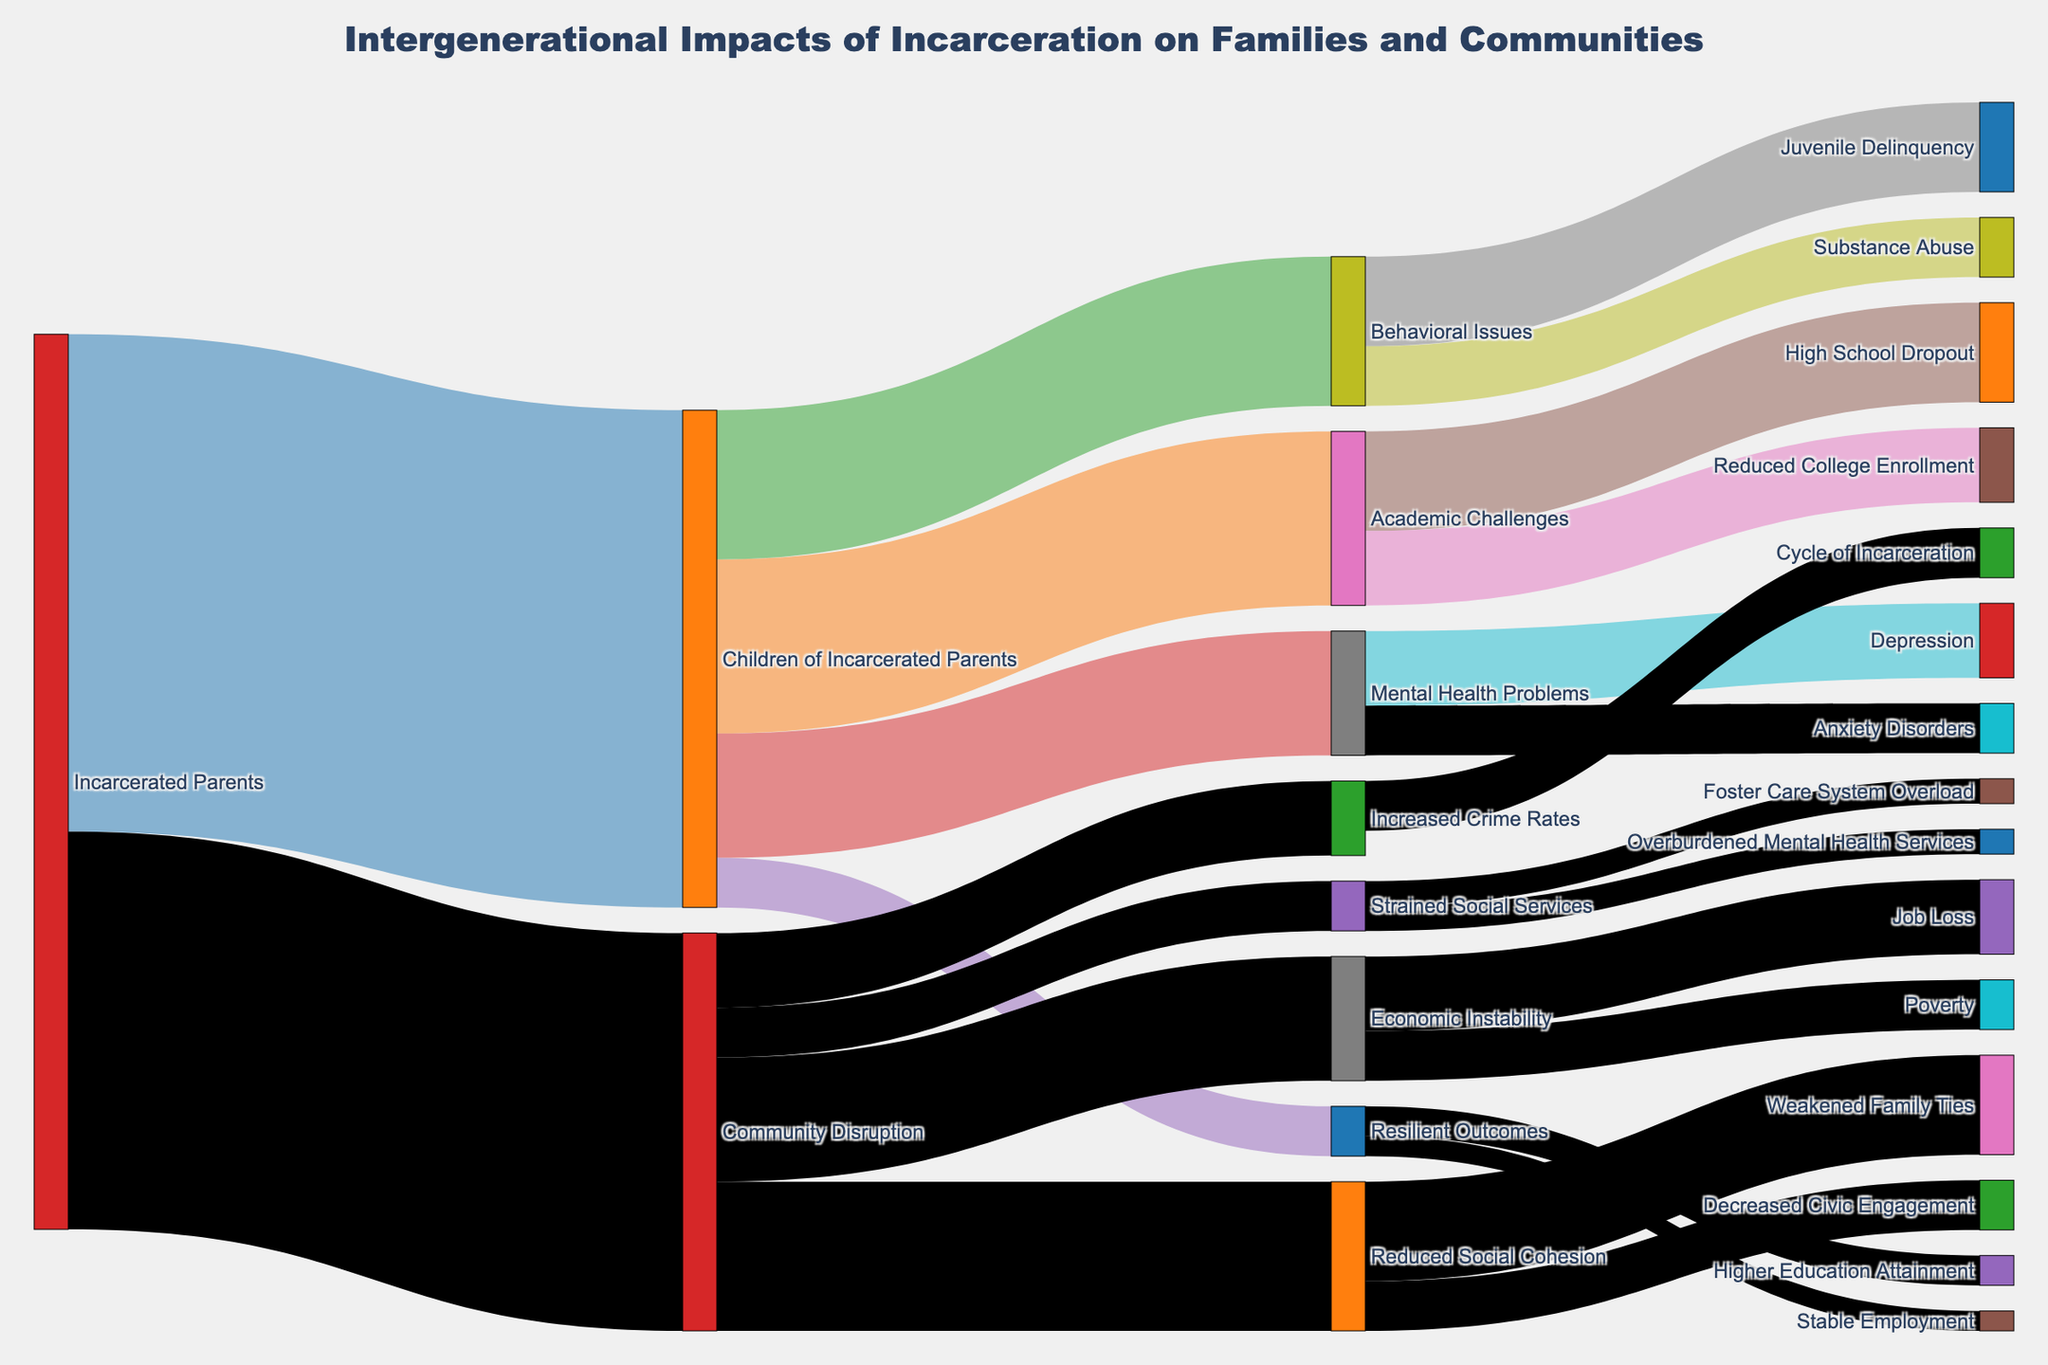What is the title of the Sankey diagram? The title is found at the top center of the Sankey diagram, providing an overview of the plot.
Answer: Intergenerational Impacts of Incarceration on Families and Communities How many children of incarcerated parents experience academic challenges? Look for the flow from "Children of Incarcerated Parents" to "Academic Challenges" and refer to the value displayed on the link.
Answer: 350 Which outcome has the least number of children of incarcerated parents? Compare the values flowing from "Children of Incarcerated Parents" to each outcome (i.e., "Academic Challenges," "Behavioral Issues," "Mental Health Problems," and "Resilient Outcomes").
Answer: Resilient Outcomes What is the total value of children experiencing adverse outcomes? Sum the values flowing into "Academic Challenges," "Behavioral Issues," and "Mental Health Problems." 350 (Academic Challenges) + 300 (Behavioral Issues) + 250 (Mental Health Problems) = 900.
Answer: 900 Between economic instability and increased crime rates, which community disruption effect has a higher impact? Compare the values flowing from "Community Disruption" to "Economic Instability" and "Increased Crime Rates."
Answer: Economic Instability How many children experience both academic challenges and mental health problems combined? Directly sum up the values flowing from "Children of Incarcerated Parents" to "Academic Challenges" and "Mental Health Problems." 350 (Academic Challenges) + 250 (Mental Health Problems) = 600.
Answer: 600 Which has a higher value, job loss due to economic instability or increased crime rates due to community disruption? Compare the values flowing to "Job Loss" and "Increased Crime Rates."
Answer: Job Loss What percentage of children of incarcerated parents show resilient outcomes? Calculate the percentage of the value for "Resilient Outcomes" out of the total value for "Children of Incarcerated Parents." (100 / 1000) * 100 = 10%.
Answer: 10% What is the difference in value between children experiencing behavioral issues and those experiencing mental health problems? Subtract the value of "Mental Health Problems" from "Behavioral Issues." 300 (Behavioral Issues) - 250 (Mental Health Problems) = 50.
Answer: 50 How many pathways lead to mental health problems due to incarceration? Count the number of links leading to "Depression" and "Anxiety Disorders" from "Mental Health Problems."
Answer: 2 